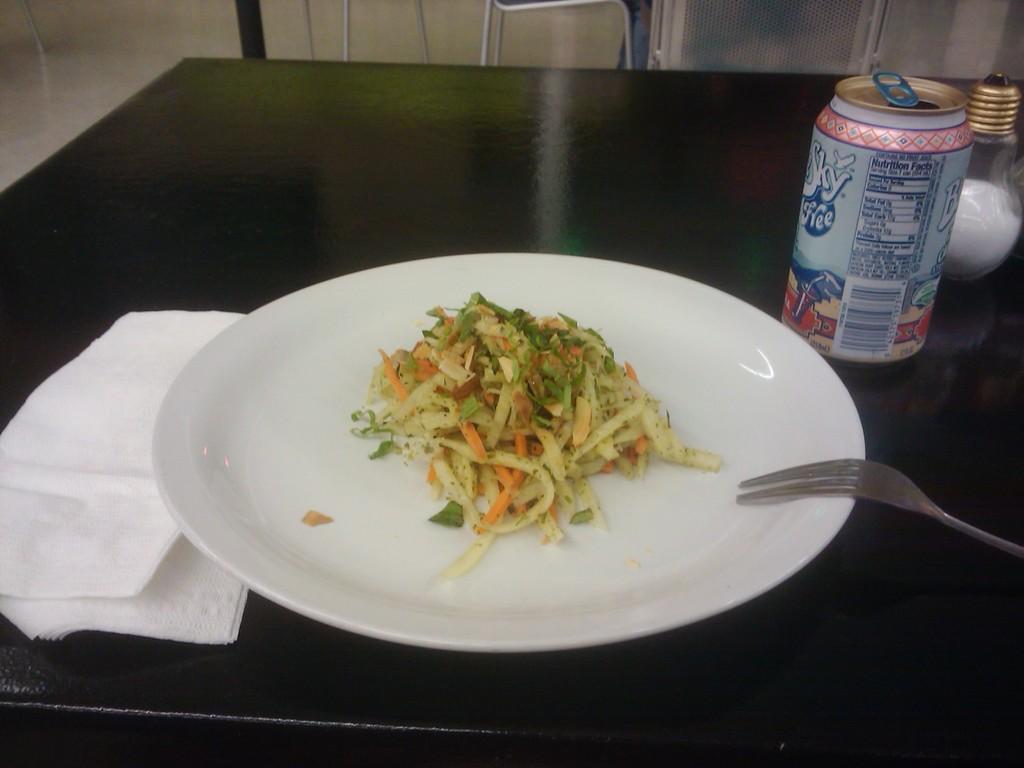Describe this image in one or two sentences. In this image we can see a table. On the table there are a beverage tin, salt container,serving plate with food on it, fork and a paper napkin. 